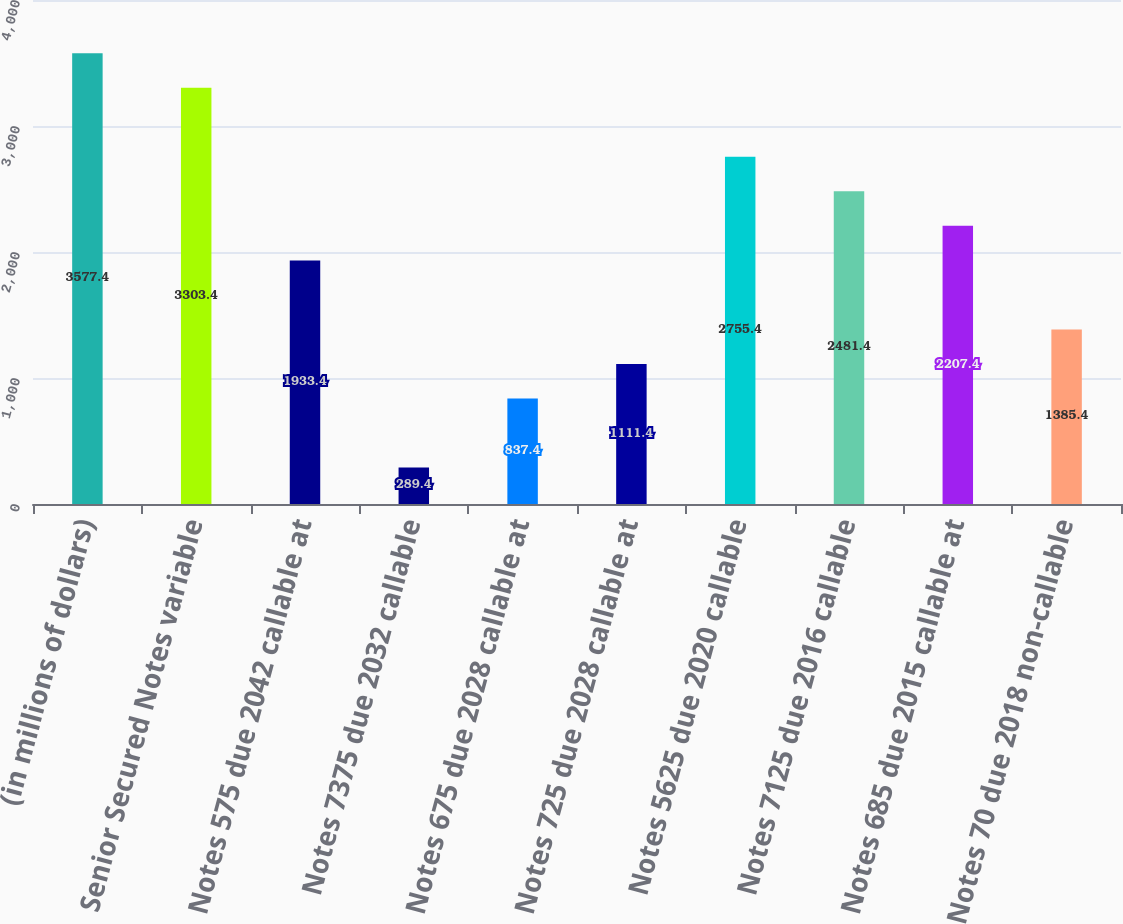Convert chart to OTSL. <chart><loc_0><loc_0><loc_500><loc_500><bar_chart><fcel>(in millions of dollars)<fcel>Senior Secured Notes variable<fcel>Notes 575 due 2042 callable at<fcel>Notes 7375 due 2032 callable<fcel>Notes 675 due 2028 callable at<fcel>Notes 725 due 2028 callable at<fcel>Notes 5625 due 2020 callable<fcel>Notes 7125 due 2016 callable<fcel>Notes 685 due 2015 callable at<fcel>Notes 70 due 2018 non-callable<nl><fcel>3577.4<fcel>3303.4<fcel>1933.4<fcel>289.4<fcel>837.4<fcel>1111.4<fcel>2755.4<fcel>2481.4<fcel>2207.4<fcel>1385.4<nl></chart> 